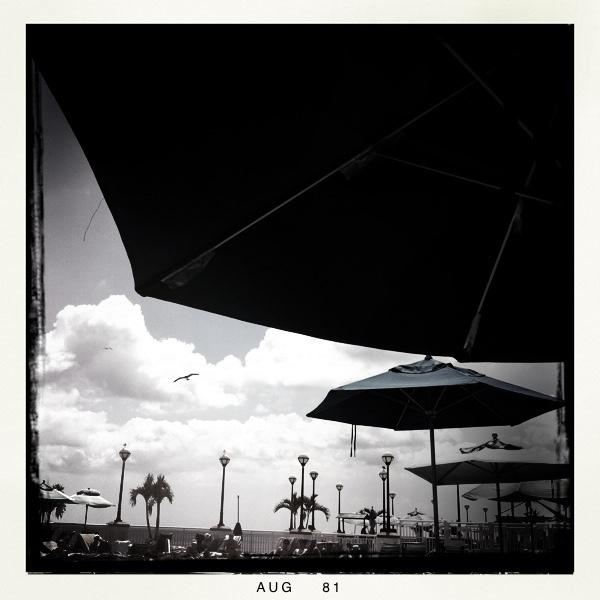Which US state is most likely to contain palm trees like the ones contained in this image? Please explain your reasoning. florida. Located in the us, this state is well known for a beach and boardwalk. 